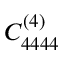<formula> <loc_0><loc_0><loc_500><loc_500>C _ { 4 4 4 4 } ^ { ( 4 ) }</formula> 